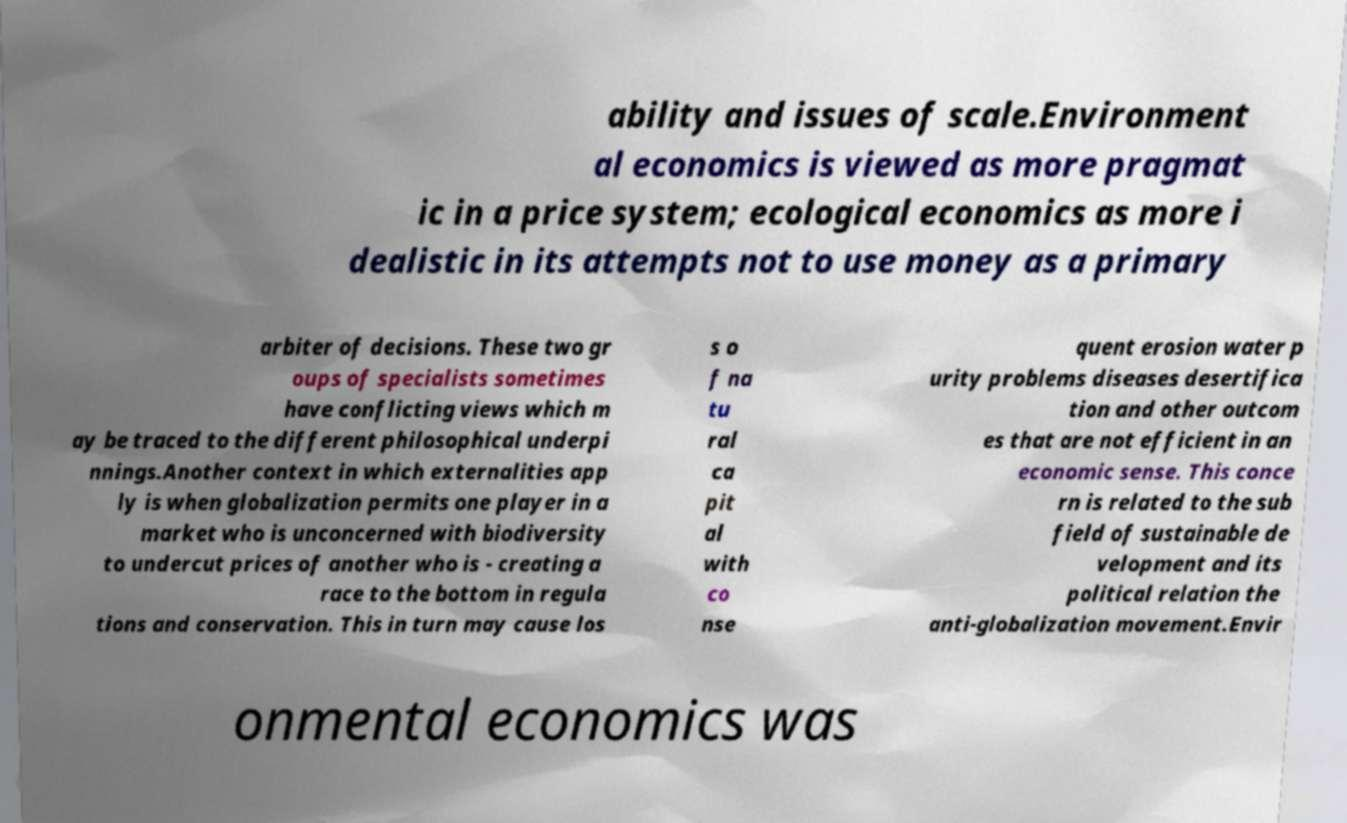Please read and relay the text visible in this image. What does it say? ability and issues of scale.Environment al economics is viewed as more pragmat ic in a price system; ecological economics as more i dealistic in its attempts not to use money as a primary arbiter of decisions. These two gr oups of specialists sometimes have conflicting views which m ay be traced to the different philosophical underpi nnings.Another context in which externalities app ly is when globalization permits one player in a market who is unconcerned with biodiversity to undercut prices of another who is - creating a race to the bottom in regula tions and conservation. This in turn may cause los s o f na tu ral ca pit al with co nse quent erosion water p urity problems diseases desertifica tion and other outcom es that are not efficient in an economic sense. This conce rn is related to the sub field of sustainable de velopment and its political relation the anti-globalization movement.Envir onmental economics was 